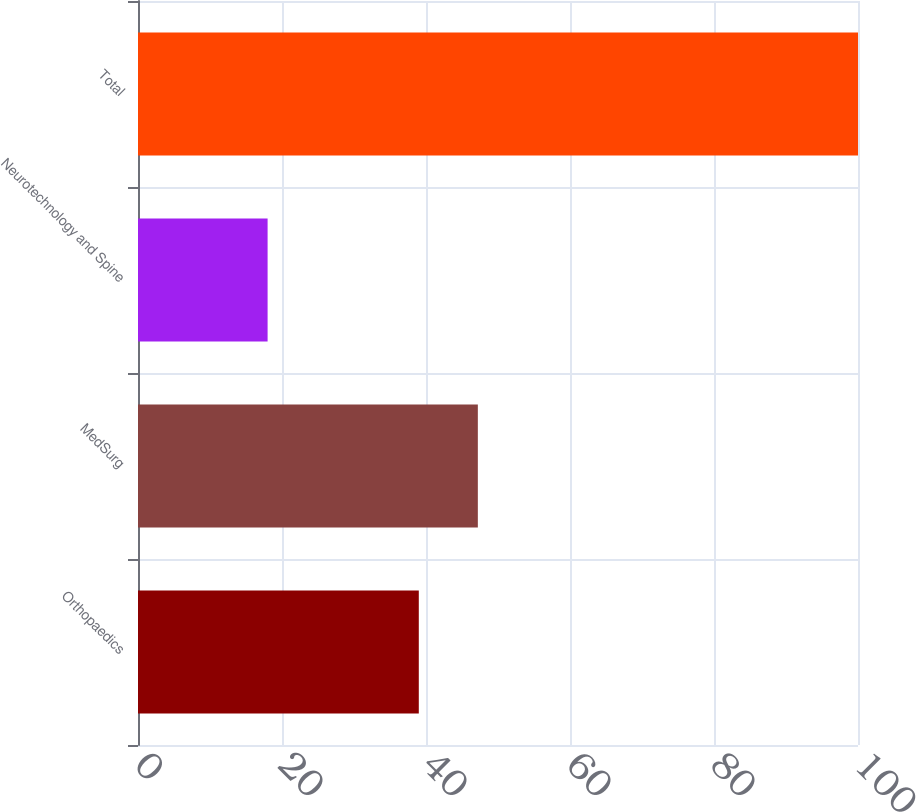Convert chart to OTSL. <chart><loc_0><loc_0><loc_500><loc_500><bar_chart><fcel>Orthopaedics<fcel>MedSurg<fcel>Neurotechnology and Spine<fcel>Total<nl><fcel>39<fcel>47.2<fcel>18<fcel>100<nl></chart> 